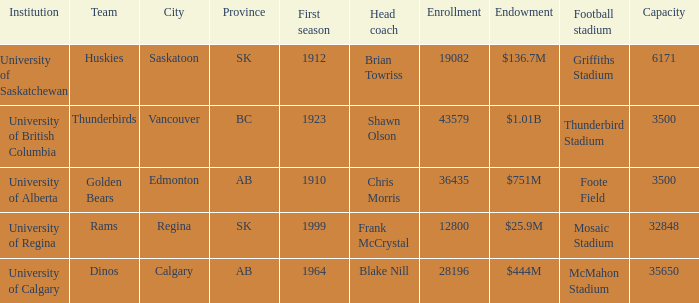What football stadium has a school enrollment of 43579? Thunderbird Stadium. 